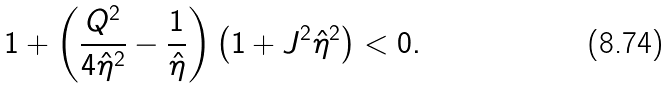Convert formula to latex. <formula><loc_0><loc_0><loc_500><loc_500>1 + \left ( \frac { Q ^ { 2 } } { 4 { \hat { \eta } } ^ { 2 } } - \frac { 1 } { \hat { \eta } } \right ) \left ( 1 + J ^ { 2 } { \hat { \eta } } ^ { 2 } \right ) < 0 .</formula> 